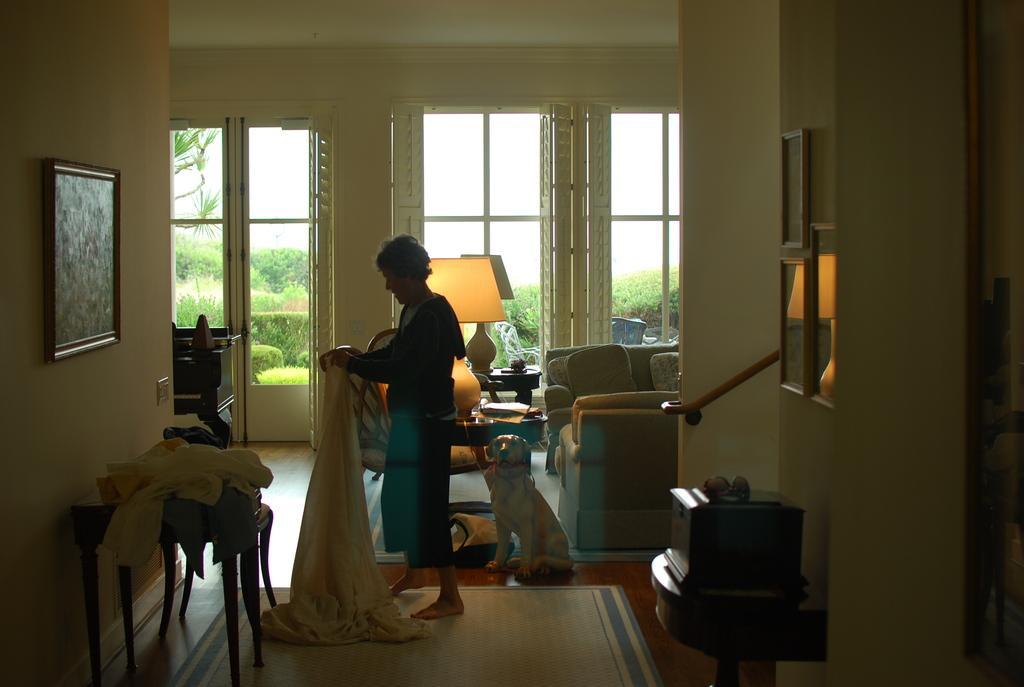Can you describe this image briefly? The picture is taken inside a house, a woman standing at folding the clothes beside her is a dog to left side there is a photo frame to the wall, behind her there is a lamp in the background windows outside that there are trees and sky. 